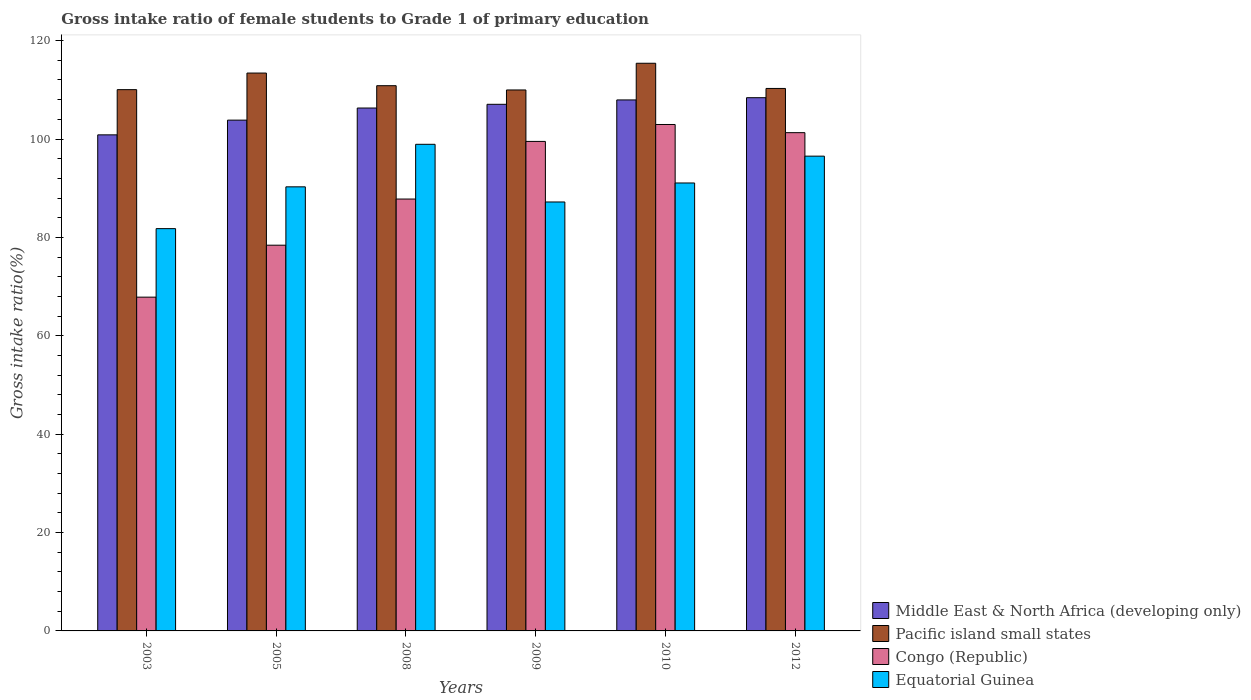How many different coloured bars are there?
Offer a terse response. 4. How many groups of bars are there?
Provide a succinct answer. 6. Are the number of bars per tick equal to the number of legend labels?
Ensure brevity in your answer.  Yes. Are the number of bars on each tick of the X-axis equal?
Provide a succinct answer. Yes. How many bars are there on the 2nd tick from the left?
Your answer should be very brief. 4. What is the label of the 6th group of bars from the left?
Keep it short and to the point. 2012. What is the gross intake ratio in Middle East & North Africa (developing only) in 2008?
Give a very brief answer. 106.3. Across all years, what is the maximum gross intake ratio in Congo (Republic)?
Ensure brevity in your answer.  102.95. Across all years, what is the minimum gross intake ratio in Pacific island small states?
Offer a very short reply. 109.97. In which year was the gross intake ratio in Middle East & North Africa (developing only) maximum?
Make the answer very short. 2012. In which year was the gross intake ratio in Pacific island small states minimum?
Provide a succinct answer. 2009. What is the total gross intake ratio in Pacific island small states in the graph?
Provide a succinct answer. 669.95. What is the difference between the gross intake ratio in Middle East & North Africa (developing only) in 2003 and that in 2008?
Offer a very short reply. -5.45. What is the difference between the gross intake ratio in Congo (Republic) in 2010 and the gross intake ratio in Equatorial Guinea in 2003?
Your answer should be compact. 21.17. What is the average gross intake ratio in Equatorial Guinea per year?
Keep it short and to the point. 90.96. In the year 2012, what is the difference between the gross intake ratio in Congo (Republic) and gross intake ratio in Equatorial Guinea?
Your response must be concise. 4.77. What is the ratio of the gross intake ratio in Equatorial Guinea in 2005 to that in 2010?
Provide a short and direct response. 0.99. What is the difference between the highest and the second highest gross intake ratio in Pacific island small states?
Your answer should be compact. 1.99. What is the difference between the highest and the lowest gross intake ratio in Pacific island small states?
Your answer should be very brief. 5.43. Is the sum of the gross intake ratio in Equatorial Guinea in 2010 and 2012 greater than the maximum gross intake ratio in Congo (Republic) across all years?
Provide a short and direct response. Yes. What does the 2nd bar from the left in 2005 represents?
Offer a very short reply. Pacific island small states. What does the 1st bar from the right in 2009 represents?
Make the answer very short. Equatorial Guinea. How many bars are there?
Provide a succinct answer. 24. How many years are there in the graph?
Make the answer very short. 6. What is the difference between two consecutive major ticks on the Y-axis?
Your response must be concise. 20. Does the graph contain grids?
Offer a very short reply. No. What is the title of the graph?
Your answer should be compact. Gross intake ratio of female students to Grade 1 of primary education. Does "St. Kitts and Nevis" appear as one of the legend labels in the graph?
Keep it short and to the point. No. What is the label or title of the Y-axis?
Your answer should be compact. Gross intake ratio(%). What is the Gross intake ratio(%) in Middle East & North Africa (developing only) in 2003?
Your answer should be compact. 100.85. What is the Gross intake ratio(%) in Pacific island small states in 2003?
Make the answer very short. 110.04. What is the Gross intake ratio(%) of Congo (Republic) in 2003?
Keep it short and to the point. 67.85. What is the Gross intake ratio(%) of Equatorial Guinea in 2003?
Provide a short and direct response. 81.78. What is the Gross intake ratio(%) in Middle East & North Africa (developing only) in 2005?
Give a very brief answer. 103.84. What is the Gross intake ratio(%) in Pacific island small states in 2005?
Provide a short and direct response. 113.41. What is the Gross intake ratio(%) in Congo (Republic) in 2005?
Provide a short and direct response. 78.42. What is the Gross intake ratio(%) of Equatorial Guinea in 2005?
Your answer should be compact. 90.28. What is the Gross intake ratio(%) in Middle East & North Africa (developing only) in 2008?
Provide a succinct answer. 106.3. What is the Gross intake ratio(%) in Pacific island small states in 2008?
Provide a short and direct response. 110.84. What is the Gross intake ratio(%) in Congo (Republic) in 2008?
Your answer should be compact. 87.8. What is the Gross intake ratio(%) of Equatorial Guinea in 2008?
Provide a short and direct response. 98.92. What is the Gross intake ratio(%) of Middle East & North Africa (developing only) in 2009?
Provide a short and direct response. 107.06. What is the Gross intake ratio(%) in Pacific island small states in 2009?
Make the answer very short. 109.97. What is the Gross intake ratio(%) in Congo (Republic) in 2009?
Give a very brief answer. 99.51. What is the Gross intake ratio(%) of Equatorial Guinea in 2009?
Keep it short and to the point. 87.2. What is the Gross intake ratio(%) in Middle East & North Africa (developing only) in 2010?
Ensure brevity in your answer.  107.95. What is the Gross intake ratio(%) in Pacific island small states in 2010?
Offer a very short reply. 115.4. What is the Gross intake ratio(%) of Congo (Republic) in 2010?
Give a very brief answer. 102.95. What is the Gross intake ratio(%) in Equatorial Guinea in 2010?
Your answer should be compact. 91.06. What is the Gross intake ratio(%) in Middle East & North Africa (developing only) in 2012?
Offer a terse response. 108.4. What is the Gross intake ratio(%) in Pacific island small states in 2012?
Your response must be concise. 110.28. What is the Gross intake ratio(%) of Congo (Republic) in 2012?
Give a very brief answer. 101.29. What is the Gross intake ratio(%) in Equatorial Guinea in 2012?
Make the answer very short. 96.52. Across all years, what is the maximum Gross intake ratio(%) in Middle East & North Africa (developing only)?
Keep it short and to the point. 108.4. Across all years, what is the maximum Gross intake ratio(%) of Pacific island small states?
Ensure brevity in your answer.  115.4. Across all years, what is the maximum Gross intake ratio(%) of Congo (Republic)?
Give a very brief answer. 102.95. Across all years, what is the maximum Gross intake ratio(%) of Equatorial Guinea?
Provide a succinct answer. 98.92. Across all years, what is the minimum Gross intake ratio(%) in Middle East & North Africa (developing only)?
Your answer should be very brief. 100.85. Across all years, what is the minimum Gross intake ratio(%) in Pacific island small states?
Provide a succinct answer. 109.97. Across all years, what is the minimum Gross intake ratio(%) in Congo (Republic)?
Your response must be concise. 67.85. Across all years, what is the minimum Gross intake ratio(%) in Equatorial Guinea?
Ensure brevity in your answer.  81.78. What is the total Gross intake ratio(%) in Middle East & North Africa (developing only) in the graph?
Provide a short and direct response. 634.39. What is the total Gross intake ratio(%) in Pacific island small states in the graph?
Your response must be concise. 669.95. What is the total Gross intake ratio(%) in Congo (Republic) in the graph?
Offer a very short reply. 537.83. What is the total Gross intake ratio(%) in Equatorial Guinea in the graph?
Give a very brief answer. 545.77. What is the difference between the Gross intake ratio(%) of Middle East & North Africa (developing only) in 2003 and that in 2005?
Your answer should be very brief. -2.99. What is the difference between the Gross intake ratio(%) in Pacific island small states in 2003 and that in 2005?
Make the answer very short. -3.37. What is the difference between the Gross intake ratio(%) of Congo (Republic) in 2003 and that in 2005?
Your response must be concise. -10.56. What is the difference between the Gross intake ratio(%) in Equatorial Guinea in 2003 and that in 2005?
Offer a terse response. -8.5. What is the difference between the Gross intake ratio(%) of Middle East & North Africa (developing only) in 2003 and that in 2008?
Your response must be concise. -5.45. What is the difference between the Gross intake ratio(%) of Pacific island small states in 2003 and that in 2008?
Offer a very short reply. -0.8. What is the difference between the Gross intake ratio(%) of Congo (Republic) in 2003 and that in 2008?
Ensure brevity in your answer.  -19.94. What is the difference between the Gross intake ratio(%) in Equatorial Guinea in 2003 and that in 2008?
Provide a short and direct response. -17.14. What is the difference between the Gross intake ratio(%) in Middle East & North Africa (developing only) in 2003 and that in 2009?
Your answer should be compact. -6.21. What is the difference between the Gross intake ratio(%) of Pacific island small states in 2003 and that in 2009?
Offer a terse response. 0.06. What is the difference between the Gross intake ratio(%) in Congo (Republic) in 2003 and that in 2009?
Give a very brief answer. -31.66. What is the difference between the Gross intake ratio(%) of Equatorial Guinea in 2003 and that in 2009?
Offer a very short reply. -5.42. What is the difference between the Gross intake ratio(%) of Middle East & North Africa (developing only) in 2003 and that in 2010?
Make the answer very short. -7.1. What is the difference between the Gross intake ratio(%) in Pacific island small states in 2003 and that in 2010?
Ensure brevity in your answer.  -5.36. What is the difference between the Gross intake ratio(%) in Congo (Republic) in 2003 and that in 2010?
Keep it short and to the point. -35.1. What is the difference between the Gross intake ratio(%) of Equatorial Guinea in 2003 and that in 2010?
Offer a very short reply. -9.28. What is the difference between the Gross intake ratio(%) of Middle East & North Africa (developing only) in 2003 and that in 2012?
Give a very brief answer. -7.55. What is the difference between the Gross intake ratio(%) in Pacific island small states in 2003 and that in 2012?
Provide a short and direct response. -0.24. What is the difference between the Gross intake ratio(%) in Congo (Republic) in 2003 and that in 2012?
Offer a terse response. -33.44. What is the difference between the Gross intake ratio(%) of Equatorial Guinea in 2003 and that in 2012?
Offer a terse response. -14.74. What is the difference between the Gross intake ratio(%) of Middle East & North Africa (developing only) in 2005 and that in 2008?
Offer a terse response. -2.46. What is the difference between the Gross intake ratio(%) of Pacific island small states in 2005 and that in 2008?
Your answer should be compact. 2.57. What is the difference between the Gross intake ratio(%) of Congo (Republic) in 2005 and that in 2008?
Provide a short and direct response. -9.38. What is the difference between the Gross intake ratio(%) in Equatorial Guinea in 2005 and that in 2008?
Provide a short and direct response. -8.64. What is the difference between the Gross intake ratio(%) in Middle East & North Africa (developing only) in 2005 and that in 2009?
Your response must be concise. -3.22. What is the difference between the Gross intake ratio(%) of Pacific island small states in 2005 and that in 2009?
Make the answer very short. 3.43. What is the difference between the Gross intake ratio(%) in Congo (Republic) in 2005 and that in 2009?
Offer a very short reply. -21.1. What is the difference between the Gross intake ratio(%) of Equatorial Guinea in 2005 and that in 2009?
Your answer should be compact. 3.08. What is the difference between the Gross intake ratio(%) in Middle East & North Africa (developing only) in 2005 and that in 2010?
Ensure brevity in your answer.  -4.11. What is the difference between the Gross intake ratio(%) of Pacific island small states in 2005 and that in 2010?
Ensure brevity in your answer.  -1.99. What is the difference between the Gross intake ratio(%) in Congo (Republic) in 2005 and that in 2010?
Ensure brevity in your answer.  -24.54. What is the difference between the Gross intake ratio(%) of Equatorial Guinea in 2005 and that in 2010?
Your answer should be compact. -0.78. What is the difference between the Gross intake ratio(%) of Middle East & North Africa (developing only) in 2005 and that in 2012?
Your answer should be very brief. -4.56. What is the difference between the Gross intake ratio(%) of Pacific island small states in 2005 and that in 2012?
Offer a very short reply. 3.13. What is the difference between the Gross intake ratio(%) of Congo (Republic) in 2005 and that in 2012?
Your answer should be compact. -22.88. What is the difference between the Gross intake ratio(%) in Equatorial Guinea in 2005 and that in 2012?
Provide a succinct answer. -6.24. What is the difference between the Gross intake ratio(%) of Middle East & North Africa (developing only) in 2008 and that in 2009?
Provide a short and direct response. -0.76. What is the difference between the Gross intake ratio(%) in Pacific island small states in 2008 and that in 2009?
Your answer should be compact. 0.87. What is the difference between the Gross intake ratio(%) in Congo (Republic) in 2008 and that in 2009?
Provide a short and direct response. -11.71. What is the difference between the Gross intake ratio(%) of Equatorial Guinea in 2008 and that in 2009?
Give a very brief answer. 11.72. What is the difference between the Gross intake ratio(%) in Middle East & North Africa (developing only) in 2008 and that in 2010?
Give a very brief answer. -1.65. What is the difference between the Gross intake ratio(%) of Pacific island small states in 2008 and that in 2010?
Make the answer very short. -4.56. What is the difference between the Gross intake ratio(%) in Congo (Republic) in 2008 and that in 2010?
Your answer should be very brief. -15.15. What is the difference between the Gross intake ratio(%) of Equatorial Guinea in 2008 and that in 2010?
Ensure brevity in your answer.  7.86. What is the difference between the Gross intake ratio(%) of Middle East & North Africa (developing only) in 2008 and that in 2012?
Ensure brevity in your answer.  -2.1. What is the difference between the Gross intake ratio(%) in Pacific island small states in 2008 and that in 2012?
Provide a short and direct response. 0.56. What is the difference between the Gross intake ratio(%) in Congo (Republic) in 2008 and that in 2012?
Make the answer very short. -13.49. What is the difference between the Gross intake ratio(%) in Equatorial Guinea in 2008 and that in 2012?
Offer a very short reply. 2.41. What is the difference between the Gross intake ratio(%) in Middle East & North Africa (developing only) in 2009 and that in 2010?
Provide a succinct answer. -0.89. What is the difference between the Gross intake ratio(%) in Pacific island small states in 2009 and that in 2010?
Your answer should be very brief. -5.43. What is the difference between the Gross intake ratio(%) in Congo (Republic) in 2009 and that in 2010?
Provide a succinct answer. -3.44. What is the difference between the Gross intake ratio(%) of Equatorial Guinea in 2009 and that in 2010?
Your response must be concise. -3.86. What is the difference between the Gross intake ratio(%) in Middle East & North Africa (developing only) in 2009 and that in 2012?
Offer a very short reply. -1.35. What is the difference between the Gross intake ratio(%) of Pacific island small states in 2009 and that in 2012?
Offer a very short reply. -0.31. What is the difference between the Gross intake ratio(%) of Congo (Republic) in 2009 and that in 2012?
Your response must be concise. -1.78. What is the difference between the Gross intake ratio(%) of Equatorial Guinea in 2009 and that in 2012?
Ensure brevity in your answer.  -9.32. What is the difference between the Gross intake ratio(%) of Middle East & North Africa (developing only) in 2010 and that in 2012?
Make the answer very short. -0.45. What is the difference between the Gross intake ratio(%) of Pacific island small states in 2010 and that in 2012?
Offer a terse response. 5.12. What is the difference between the Gross intake ratio(%) in Congo (Republic) in 2010 and that in 2012?
Keep it short and to the point. 1.66. What is the difference between the Gross intake ratio(%) of Equatorial Guinea in 2010 and that in 2012?
Provide a succinct answer. -5.46. What is the difference between the Gross intake ratio(%) of Middle East & North Africa (developing only) in 2003 and the Gross intake ratio(%) of Pacific island small states in 2005?
Offer a terse response. -12.56. What is the difference between the Gross intake ratio(%) in Middle East & North Africa (developing only) in 2003 and the Gross intake ratio(%) in Congo (Republic) in 2005?
Ensure brevity in your answer.  22.43. What is the difference between the Gross intake ratio(%) of Middle East & North Africa (developing only) in 2003 and the Gross intake ratio(%) of Equatorial Guinea in 2005?
Provide a succinct answer. 10.57. What is the difference between the Gross intake ratio(%) in Pacific island small states in 2003 and the Gross intake ratio(%) in Congo (Republic) in 2005?
Provide a short and direct response. 31.62. What is the difference between the Gross intake ratio(%) in Pacific island small states in 2003 and the Gross intake ratio(%) in Equatorial Guinea in 2005?
Provide a short and direct response. 19.76. What is the difference between the Gross intake ratio(%) in Congo (Republic) in 2003 and the Gross intake ratio(%) in Equatorial Guinea in 2005?
Offer a very short reply. -22.43. What is the difference between the Gross intake ratio(%) in Middle East & North Africa (developing only) in 2003 and the Gross intake ratio(%) in Pacific island small states in 2008?
Ensure brevity in your answer.  -9.99. What is the difference between the Gross intake ratio(%) in Middle East & North Africa (developing only) in 2003 and the Gross intake ratio(%) in Congo (Republic) in 2008?
Provide a succinct answer. 13.05. What is the difference between the Gross intake ratio(%) of Middle East & North Africa (developing only) in 2003 and the Gross intake ratio(%) of Equatorial Guinea in 2008?
Your answer should be compact. 1.92. What is the difference between the Gross intake ratio(%) of Pacific island small states in 2003 and the Gross intake ratio(%) of Congo (Republic) in 2008?
Give a very brief answer. 22.24. What is the difference between the Gross intake ratio(%) of Pacific island small states in 2003 and the Gross intake ratio(%) of Equatorial Guinea in 2008?
Give a very brief answer. 11.11. What is the difference between the Gross intake ratio(%) of Congo (Republic) in 2003 and the Gross intake ratio(%) of Equatorial Guinea in 2008?
Your answer should be compact. -31.07. What is the difference between the Gross intake ratio(%) in Middle East & North Africa (developing only) in 2003 and the Gross intake ratio(%) in Pacific island small states in 2009?
Ensure brevity in your answer.  -9.13. What is the difference between the Gross intake ratio(%) in Middle East & North Africa (developing only) in 2003 and the Gross intake ratio(%) in Congo (Republic) in 2009?
Offer a very short reply. 1.33. What is the difference between the Gross intake ratio(%) in Middle East & North Africa (developing only) in 2003 and the Gross intake ratio(%) in Equatorial Guinea in 2009?
Offer a very short reply. 13.65. What is the difference between the Gross intake ratio(%) in Pacific island small states in 2003 and the Gross intake ratio(%) in Congo (Republic) in 2009?
Provide a short and direct response. 10.52. What is the difference between the Gross intake ratio(%) in Pacific island small states in 2003 and the Gross intake ratio(%) in Equatorial Guinea in 2009?
Provide a succinct answer. 22.84. What is the difference between the Gross intake ratio(%) of Congo (Republic) in 2003 and the Gross intake ratio(%) of Equatorial Guinea in 2009?
Your response must be concise. -19.35. What is the difference between the Gross intake ratio(%) of Middle East & North Africa (developing only) in 2003 and the Gross intake ratio(%) of Pacific island small states in 2010?
Ensure brevity in your answer.  -14.55. What is the difference between the Gross intake ratio(%) of Middle East & North Africa (developing only) in 2003 and the Gross intake ratio(%) of Congo (Republic) in 2010?
Your answer should be very brief. -2.1. What is the difference between the Gross intake ratio(%) in Middle East & North Africa (developing only) in 2003 and the Gross intake ratio(%) in Equatorial Guinea in 2010?
Provide a short and direct response. 9.79. What is the difference between the Gross intake ratio(%) of Pacific island small states in 2003 and the Gross intake ratio(%) of Congo (Republic) in 2010?
Keep it short and to the point. 7.09. What is the difference between the Gross intake ratio(%) of Pacific island small states in 2003 and the Gross intake ratio(%) of Equatorial Guinea in 2010?
Provide a succinct answer. 18.98. What is the difference between the Gross intake ratio(%) of Congo (Republic) in 2003 and the Gross intake ratio(%) of Equatorial Guinea in 2010?
Offer a terse response. -23.21. What is the difference between the Gross intake ratio(%) in Middle East & North Africa (developing only) in 2003 and the Gross intake ratio(%) in Pacific island small states in 2012?
Make the answer very short. -9.43. What is the difference between the Gross intake ratio(%) of Middle East & North Africa (developing only) in 2003 and the Gross intake ratio(%) of Congo (Republic) in 2012?
Your response must be concise. -0.44. What is the difference between the Gross intake ratio(%) in Middle East & North Africa (developing only) in 2003 and the Gross intake ratio(%) in Equatorial Guinea in 2012?
Ensure brevity in your answer.  4.33. What is the difference between the Gross intake ratio(%) of Pacific island small states in 2003 and the Gross intake ratio(%) of Congo (Republic) in 2012?
Keep it short and to the point. 8.75. What is the difference between the Gross intake ratio(%) in Pacific island small states in 2003 and the Gross intake ratio(%) in Equatorial Guinea in 2012?
Offer a very short reply. 13.52. What is the difference between the Gross intake ratio(%) in Congo (Republic) in 2003 and the Gross intake ratio(%) in Equatorial Guinea in 2012?
Provide a short and direct response. -28.66. What is the difference between the Gross intake ratio(%) of Middle East & North Africa (developing only) in 2005 and the Gross intake ratio(%) of Pacific island small states in 2008?
Give a very brief answer. -7. What is the difference between the Gross intake ratio(%) of Middle East & North Africa (developing only) in 2005 and the Gross intake ratio(%) of Congo (Republic) in 2008?
Provide a short and direct response. 16.04. What is the difference between the Gross intake ratio(%) of Middle East & North Africa (developing only) in 2005 and the Gross intake ratio(%) of Equatorial Guinea in 2008?
Ensure brevity in your answer.  4.91. What is the difference between the Gross intake ratio(%) of Pacific island small states in 2005 and the Gross intake ratio(%) of Congo (Republic) in 2008?
Keep it short and to the point. 25.61. What is the difference between the Gross intake ratio(%) of Pacific island small states in 2005 and the Gross intake ratio(%) of Equatorial Guinea in 2008?
Give a very brief answer. 14.48. What is the difference between the Gross intake ratio(%) of Congo (Republic) in 2005 and the Gross intake ratio(%) of Equatorial Guinea in 2008?
Offer a very short reply. -20.51. What is the difference between the Gross intake ratio(%) of Middle East & North Africa (developing only) in 2005 and the Gross intake ratio(%) of Pacific island small states in 2009?
Ensure brevity in your answer.  -6.14. What is the difference between the Gross intake ratio(%) of Middle East & North Africa (developing only) in 2005 and the Gross intake ratio(%) of Congo (Republic) in 2009?
Your answer should be very brief. 4.32. What is the difference between the Gross intake ratio(%) in Middle East & North Africa (developing only) in 2005 and the Gross intake ratio(%) in Equatorial Guinea in 2009?
Ensure brevity in your answer.  16.64. What is the difference between the Gross intake ratio(%) of Pacific island small states in 2005 and the Gross intake ratio(%) of Congo (Republic) in 2009?
Give a very brief answer. 13.89. What is the difference between the Gross intake ratio(%) of Pacific island small states in 2005 and the Gross intake ratio(%) of Equatorial Guinea in 2009?
Provide a short and direct response. 26.21. What is the difference between the Gross intake ratio(%) of Congo (Republic) in 2005 and the Gross intake ratio(%) of Equatorial Guinea in 2009?
Your answer should be very brief. -8.79. What is the difference between the Gross intake ratio(%) in Middle East & North Africa (developing only) in 2005 and the Gross intake ratio(%) in Pacific island small states in 2010?
Ensure brevity in your answer.  -11.56. What is the difference between the Gross intake ratio(%) of Middle East & North Africa (developing only) in 2005 and the Gross intake ratio(%) of Congo (Republic) in 2010?
Keep it short and to the point. 0.89. What is the difference between the Gross intake ratio(%) in Middle East & North Africa (developing only) in 2005 and the Gross intake ratio(%) in Equatorial Guinea in 2010?
Your answer should be compact. 12.78. What is the difference between the Gross intake ratio(%) of Pacific island small states in 2005 and the Gross intake ratio(%) of Congo (Republic) in 2010?
Make the answer very short. 10.46. What is the difference between the Gross intake ratio(%) of Pacific island small states in 2005 and the Gross intake ratio(%) of Equatorial Guinea in 2010?
Your answer should be very brief. 22.35. What is the difference between the Gross intake ratio(%) of Congo (Republic) in 2005 and the Gross intake ratio(%) of Equatorial Guinea in 2010?
Your response must be concise. -12.65. What is the difference between the Gross intake ratio(%) of Middle East & North Africa (developing only) in 2005 and the Gross intake ratio(%) of Pacific island small states in 2012?
Your answer should be very brief. -6.44. What is the difference between the Gross intake ratio(%) in Middle East & North Africa (developing only) in 2005 and the Gross intake ratio(%) in Congo (Republic) in 2012?
Provide a short and direct response. 2.55. What is the difference between the Gross intake ratio(%) in Middle East & North Africa (developing only) in 2005 and the Gross intake ratio(%) in Equatorial Guinea in 2012?
Provide a succinct answer. 7.32. What is the difference between the Gross intake ratio(%) of Pacific island small states in 2005 and the Gross intake ratio(%) of Congo (Republic) in 2012?
Offer a terse response. 12.12. What is the difference between the Gross intake ratio(%) of Pacific island small states in 2005 and the Gross intake ratio(%) of Equatorial Guinea in 2012?
Ensure brevity in your answer.  16.89. What is the difference between the Gross intake ratio(%) in Congo (Republic) in 2005 and the Gross intake ratio(%) in Equatorial Guinea in 2012?
Offer a very short reply. -18.1. What is the difference between the Gross intake ratio(%) in Middle East & North Africa (developing only) in 2008 and the Gross intake ratio(%) in Pacific island small states in 2009?
Your answer should be compact. -3.67. What is the difference between the Gross intake ratio(%) in Middle East & North Africa (developing only) in 2008 and the Gross intake ratio(%) in Congo (Republic) in 2009?
Make the answer very short. 6.79. What is the difference between the Gross intake ratio(%) of Middle East & North Africa (developing only) in 2008 and the Gross intake ratio(%) of Equatorial Guinea in 2009?
Your answer should be very brief. 19.1. What is the difference between the Gross intake ratio(%) in Pacific island small states in 2008 and the Gross intake ratio(%) in Congo (Republic) in 2009?
Your answer should be compact. 11.33. What is the difference between the Gross intake ratio(%) of Pacific island small states in 2008 and the Gross intake ratio(%) of Equatorial Guinea in 2009?
Give a very brief answer. 23.64. What is the difference between the Gross intake ratio(%) in Congo (Republic) in 2008 and the Gross intake ratio(%) in Equatorial Guinea in 2009?
Offer a terse response. 0.6. What is the difference between the Gross intake ratio(%) in Middle East & North Africa (developing only) in 2008 and the Gross intake ratio(%) in Pacific island small states in 2010?
Ensure brevity in your answer.  -9.1. What is the difference between the Gross intake ratio(%) in Middle East & North Africa (developing only) in 2008 and the Gross intake ratio(%) in Congo (Republic) in 2010?
Give a very brief answer. 3.35. What is the difference between the Gross intake ratio(%) in Middle East & North Africa (developing only) in 2008 and the Gross intake ratio(%) in Equatorial Guinea in 2010?
Your answer should be very brief. 15.24. What is the difference between the Gross intake ratio(%) in Pacific island small states in 2008 and the Gross intake ratio(%) in Congo (Republic) in 2010?
Your answer should be very brief. 7.89. What is the difference between the Gross intake ratio(%) of Pacific island small states in 2008 and the Gross intake ratio(%) of Equatorial Guinea in 2010?
Your response must be concise. 19.78. What is the difference between the Gross intake ratio(%) of Congo (Republic) in 2008 and the Gross intake ratio(%) of Equatorial Guinea in 2010?
Provide a short and direct response. -3.26. What is the difference between the Gross intake ratio(%) in Middle East & North Africa (developing only) in 2008 and the Gross intake ratio(%) in Pacific island small states in 2012?
Keep it short and to the point. -3.98. What is the difference between the Gross intake ratio(%) in Middle East & North Africa (developing only) in 2008 and the Gross intake ratio(%) in Congo (Republic) in 2012?
Your answer should be compact. 5.01. What is the difference between the Gross intake ratio(%) in Middle East & North Africa (developing only) in 2008 and the Gross intake ratio(%) in Equatorial Guinea in 2012?
Your answer should be very brief. 9.78. What is the difference between the Gross intake ratio(%) in Pacific island small states in 2008 and the Gross intake ratio(%) in Congo (Republic) in 2012?
Your answer should be compact. 9.55. What is the difference between the Gross intake ratio(%) of Pacific island small states in 2008 and the Gross intake ratio(%) of Equatorial Guinea in 2012?
Provide a short and direct response. 14.32. What is the difference between the Gross intake ratio(%) in Congo (Republic) in 2008 and the Gross intake ratio(%) in Equatorial Guinea in 2012?
Your response must be concise. -8.72. What is the difference between the Gross intake ratio(%) of Middle East & North Africa (developing only) in 2009 and the Gross intake ratio(%) of Pacific island small states in 2010?
Provide a short and direct response. -8.35. What is the difference between the Gross intake ratio(%) in Middle East & North Africa (developing only) in 2009 and the Gross intake ratio(%) in Congo (Republic) in 2010?
Keep it short and to the point. 4.1. What is the difference between the Gross intake ratio(%) in Middle East & North Africa (developing only) in 2009 and the Gross intake ratio(%) in Equatorial Guinea in 2010?
Your response must be concise. 15.99. What is the difference between the Gross intake ratio(%) of Pacific island small states in 2009 and the Gross intake ratio(%) of Congo (Republic) in 2010?
Ensure brevity in your answer.  7.02. What is the difference between the Gross intake ratio(%) of Pacific island small states in 2009 and the Gross intake ratio(%) of Equatorial Guinea in 2010?
Ensure brevity in your answer.  18.91. What is the difference between the Gross intake ratio(%) in Congo (Republic) in 2009 and the Gross intake ratio(%) in Equatorial Guinea in 2010?
Provide a short and direct response. 8.45. What is the difference between the Gross intake ratio(%) of Middle East & North Africa (developing only) in 2009 and the Gross intake ratio(%) of Pacific island small states in 2012?
Offer a very short reply. -3.23. What is the difference between the Gross intake ratio(%) of Middle East & North Africa (developing only) in 2009 and the Gross intake ratio(%) of Congo (Republic) in 2012?
Your answer should be compact. 5.76. What is the difference between the Gross intake ratio(%) in Middle East & North Africa (developing only) in 2009 and the Gross intake ratio(%) in Equatorial Guinea in 2012?
Offer a terse response. 10.54. What is the difference between the Gross intake ratio(%) of Pacific island small states in 2009 and the Gross intake ratio(%) of Congo (Republic) in 2012?
Your answer should be very brief. 8.68. What is the difference between the Gross intake ratio(%) in Pacific island small states in 2009 and the Gross intake ratio(%) in Equatorial Guinea in 2012?
Provide a short and direct response. 13.46. What is the difference between the Gross intake ratio(%) of Congo (Republic) in 2009 and the Gross intake ratio(%) of Equatorial Guinea in 2012?
Offer a very short reply. 3. What is the difference between the Gross intake ratio(%) of Middle East & North Africa (developing only) in 2010 and the Gross intake ratio(%) of Pacific island small states in 2012?
Ensure brevity in your answer.  -2.33. What is the difference between the Gross intake ratio(%) in Middle East & North Africa (developing only) in 2010 and the Gross intake ratio(%) in Congo (Republic) in 2012?
Give a very brief answer. 6.66. What is the difference between the Gross intake ratio(%) of Middle East & North Africa (developing only) in 2010 and the Gross intake ratio(%) of Equatorial Guinea in 2012?
Give a very brief answer. 11.43. What is the difference between the Gross intake ratio(%) in Pacific island small states in 2010 and the Gross intake ratio(%) in Congo (Republic) in 2012?
Offer a terse response. 14.11. What is the difference between the Gross intake ratio(%) of Pacific island small states in 2010 and the Gross intake ratio(%) of Equatorial Guinea in 2012?
Keep it short and to the point. 18.88. What is the difference between the Gross intake ratio(%) in Congo (Republic) in 2010 and the Gross intake ratio(%) in Equatorial Guinea in 2012?
Keep it short and to the point. 6.43. What is the average Gross intake ratio(%) of Middle East & North Africa (developing only) per year?
Give a very brief answer. 105.73. What is the average Gross intake ratio(%) in Pacific island small states per year?
Your answer should be compact. 111.66. What is the average Gross intake ratio(%) in Congo (Republic) per year?
Ensure brevity in your answer.  89.64. What is the average Gross intake ratio(%) in Equatorial Guinea per year?
Make the answer very short. 90.96. In the year 2003, what is the difference between the Gross intake ratio(%) of Middle East & North Africa (developing only) and Gross intake ratio(%) of Pacific island small states?
Provide a succinct answer. -9.19. In the year 2003, what is the difference between the Gross intake ratio(%) of Middle East & North Africa (developing only) and Gross intake ratio(%) of Congo (Republic)?
Your answer should be very brief. 32.99. In the year 2003, what is the difference between the Gross intake ratio(%) of Middle East & North Africa (developing only) and Gross intake ratio(%) of Equatorial Guinea?
Provide a succinct answer. 19.07. In the year 2003, what is the difference between the Gross intake ratio(%) in Pacific island small states and Gross intake ratio(%) in Congo (Republic)?
Give a very brief answer. 42.18. In the year 2003, what is the difference between the Gross intake ratio(%) of Pacific island small states and Gross intake ratio(%) of Equatorial Guinea?
Your answer should be compact. 28.26. In the year 2003, what is the difference between the Gross intake ratio(%) of Congo (Republic) and Gross intake ratio(%) of Equatorial Guinea?
Provide a short and direct response. -13.93. In the year 2005, what is the difference between the Gross intake ratio(%) of Middle East & North Africa (developing only) and Gross intake ratio(%) of Pacific island small states?
Your response must be concise. -9.57. In the year 2005, what is the difference between the Gross intake ratio(%) of Middle East & North Africa (developing only) and Gross intake ratio(%) of Congo (Republic)?
Ensure brevity in your answer.  25.42. In the year 2005, what is the difference between the Gross intake ratio(%) of Middle East & North Africa (developing only) and Gross intake ratio(%) of Equatorial Guinea?
Provide a short and direct response. 13.56. In the year 2005, what is the difference between the Gross intake ratio(%) in Pacific island small states and Gross intake ratio(%) in Congo (Republic)?
Provide a succinct answer. 34.99. In the year 2005, what is the difference between the Gross intake ratio(%) of Pacific island small states and Gross intake ratio(%) of Equatorial Guinea?
Your answer should be compact. 23.13. In the year 2005, what is the difference between the Gross intake ratio(%) of Congo (Republic) and Gross intake ratio(%) of Equatorial Guinea?
Give a very brief answer. -11.86. In the year 2008, what is the difference between the Gross intake ratio(%) of Middle East & North Africa (developing only) and Gross intake ratio(%) of Pacific island small states?
Your answer should be very brief. -4.54. In the year 2008, what is the difference between the Gross intake ratio(%) in Middle East & North Africa (developing only) and Gross intake ratio(%) in Congo (Republic)?
Your answer should be very brief. 18.5. In the year 2008, what is the difference between the Gross intake ratio(%) in Middle East & North Africa (developing only) and Gross intake ratio(%) in Equatorial Guinea?
Provide a short and direct response. 7.38. In the year 2008, what is the difference between the Gross intake ratio(%) in Pacific island small states and Gross intake ratio(%) in Congo (Republic)?
Ensure brevity in your answer.  23.04. In the year 2008, what is the difference between the Gross intake ratio(%) of Pacific island small states and Gross intake ratio(%) of Equatorial Guinea?
Offer a terse response. 11.92. In the year 2008, what is the difference between the Gross intake ratio(%) of Congo (Republic) and Gross intake ratio(%) of Equatorial Guinea?
Keep it short and to the point. -11.12. In the year 2009, what is the difference between the Gross intake ratio(%) of Middle East & North Africa (developing only) and Gross intake ratio(%) of Pacific island small states?
Keep it short and to the point. -2.92. In the year 2009, what is the difference between the Gross intake ratio(%) of Middle East & North Africa (developing only) and Gross intake ratio(%) of Congo (Republic)?
Offer a terse response. 7.54. In the year 2009, what is the difference between the Gross intake ratio(%) of Middle East & North Africa (developing only) and Gross intake ratio(%) of Equatorial Guinea?
Give a very brief answer. 19.86. In the year 2009, what is the difference between the Gross intake ratio(%) of Pacific island small states and Gross intake ratio(%) of Congo (Republic)?
Keep it short and to the point. 10.46. In the year 2009, what is the difference between the Gross intake ratio(%) of Pacific island small states and Gross intake ratio(%) of Equatorial Guinea?
Your answer should be compact. 22.77. In the year 2009, what is the difference between the Gross intake ratio(%) of Congo (Republic) and Gross intake ratio(%) of Equatorial Guinea?
Provide a short and direct response. 12.31. In the year 2010, what is the difference between the Gross intake ratio(%) of Middle East & North Africa (developing only) and Gross intake ratio(%) of Pacific island small states?
Make the answer very short. -7.45. In the year 2010, what is the difference between the Gross intake ratio(%) of Middle East & North Africa (developing only) and Gross intake ratio(%) of Congo (Republic)?
Offer a very short reply. 5. In the year 2010, what is the difference between the Gross intake ratio(%) of Middle East & North Africa (developing only) and Gross intake ratio(%) of Equatorial Guinea?
Give a very brief answer. 16.89. In the year 2010, what is the difference between the Gross intake ratio(%) of Pacific island small states and Gross intake ratio(%) of Congo (Republic)?
Your answer should be compact. 12.45. In the year 2010, what is the difference between the Gross intake ratio(%) in Pacific island small states and Gross intake ratio(%) in Equatorial Guinea?
Offer a terse response. 24.34. In the year 2010, what is the difference between the Gross intake ratio(%) in Congo (Republic) and Gross intake ratio(%) in Equatorial Guinea?
Give a very brief answer. 11.89. In the year 2012, what is the difference between the Gross intake ratio(%) in Middle East & North Africa (developing only) and Gross intake ratio(%) in Pacific island small states?
Offer a very short reply. -1.88. In the year 2012, what is the difference between the Gross intake ratio(%) of Middle East & North Africa (developing only) and Gross intake ratio(%) of Congo (Republic)?
Make the answer very short. 7.11. In the year 2012, what is the difference between the Gross intake ratio(%) in Middle East & North Africa (developing only) and Gross intake ratio(%) in Equatorial Guinea?
Your response must be concise. 11.88. In the year 2012, what is the difference between the Gross intake ratio(%) of Pacific island small states and Gross intake ratio(%) of Congo (Republic)?
Make the answer very short. 8.99. In the year 2012, what is the difference between the Gross intake ratio(%) in Pacific island small states and Gross intake ratio(%) in Equatorial Guinea?
Your answer should be compact. 13.76. In the year 2012, what is the difference between the Gross intake ratio(%) of Congo (Republic) and Gross intake ratio(%) of Equatorial Guinea?
Keep it short and to the point. 4.77. What is the ratio of the Gross intake ratio(%) in Middle East & North Africa (developing only) in 2003 to that in 2005?
Keep it short and to the point. 0.97. What is the ratio of the Gross intake ratio(%) in Pacific island small states in 2003 to that in 2005?
Ensure brevity in your answer.  0.97. What is the ratio of the Gross intake ratio(%) of Congo (Republic) in 2003 to that in 2005?
Provide a short and direct response. 0.87. What is the ratio of the Gross intake ratio(%) of Equatorial Guinea in 2003 to that in 2005?
Make the answer very short. 0.91. What is the ratio of the Gross intake ratio(%) in Middle East & North Africa (developing only) in 2003 to that in 2008?
Your response must be concise. 0.95. What is the ratio of the Gross intake ratio(%) in Congo (Republic) in 2003 to that in 2008?
Keep it short and to the point. 0.77. What is the ratio of the Gross intake ratio(%) in Equatorial Guinea in 2003 to that in 2008?
Provide a succinct answer. 0.83. What is the ratio of the Gross intake ratio(%) of Middle East & North Africa (developing only) in 2003 to that in 2009?
Your answer should be very brief. 0.94. What is the ratio of the Gross intake ratio(%) in Pacific island small states in 2003 to that in 2009?
Keep it short and to the point. 1. What is the ratio of the Gross intake ratio(%) of Congo (Republic) in 2003 to that in 2009?
Offer a terse response. 0.68. What is the ratio of the Gross intake ratio(%) of Equatorial Guinea in 2003 to that in 2009?
Provide a short and direct response. 0.94. What is the ratio of the Gross intake ratio(%) in Middle East & North Africa (developing only) in 2003 to that in 2010?
Make the answer very short. 0.93. What is the ratio of the Gross intake ratio(%) of Pacific island small states in 2003 to that in 2010?
Give a very brief answer. 0.95. What is the ratio of the Gross intake ratio(%) in Congo (Republic) in 2003 to that in 2010?
Your answer should be very brief. 0.66. What is the ratio of the Gross intake ratio(%) of Equatorial Guinea in 2003 to that in 2010?
Your answer should be very brief. 0.9. What is the ratio of the Gross intake ratio(%) of Middle East & North Africa (developing only) in 2003 to that in 2012?
Provide a succinct answer. 0.93. What is the ratio of the Gross intake ratio(%) in Congo (Republic) in 2003 to that in 2012?
Your answer should be very brief. 0.67. What is the ratio of the Gross intake ratio(%) in Equatorial Guinea in 2003 to that in 2012?
Your response must be concise. 0.85. What is the ratio of the Gross intake ratio(%) in Middle East & North Africa (developing only) in 2005 to that in 2008?
Your answer should be compact. 0.98. What is the ratio of the Gross intake ratio(%) in Pacific island small states in 2005 to that in 2008?
Ensure brevity in your answer.  1.02. What is the ratio of the Gross intake ratio(%) of Congo (Republic) in 2005 to that in 2008?
Keep it short and to the point. 0.89. What is the ratio of the Gross intake ratio(%) in Equatorial Guinea in 2005 to that in 2008?
Offer a terse response. 0.91. What is the ratio of the Gross intake ratio(%) of Pacific island small states in 2005 to that in 2009?
Provide a succinct answer. 1.03. What is the ratio of the Gross intake ratio(%) in Congo (Republic) in 2005 to that in 2009?
Provide a short and direct response. 0.79. What is the ratio of the Gross intake ratio(%) in Equatorial Guinea in 2005 to that in 2009?
Your answer should be very brief. 1.04. What is the ratio of the Gross intake ratio(%) in Middle East & North Africa (developing only) in 2005 to that in 2010?
Your answer should be very brief. 0.96. What is the ratio of the Gross intake ratio(%) of Pacific island small states in 2005 to that in 2010?
Make the answer very short. 0.98. What is the ratio of the Gross intake ratio(%) of Congo (Republic) in 2005 to that in 2010?
Make the answer very short. 0.76. What is the ratio of the Gross intake ratio(%) in Equatorial Guinea in 2005 to that in 2010?
Your response must be concise. 0.99. What is the ratio of the Gross intake ratio(%) of Middle East & North Africa (developing only) in 2005 to that in 2012?
Keep it short and to the point. 0.96. What is the ratio of the Gross intake ratio(%) in Pacific island small states in 2005 to that in 2012?
Ensure brevity in your answer.  1.03. What is the ratio of the Gross intake ratio(%) of Congo (Republic) in 2005 to that in 2012?
Give a very brief answer. 0.77. What is the ratio of the Gross intake ratio(%) of Equatorial Guinea in 2005 to that in 2012?
Offer a terse response. 0.94. What is the ratio of the Gross intake ratio(%) in Pacific island small states in 2008 to that in 2009?
Offer a terse response. 1.01. What is the ratio of the Gross intake ratio(%) in Congo (Republic) in 2008 to that in 2009?
Provide a succinct answer. 0.88. What is the ratio of the Gross intake ratio(%) of Equatorial Guinea in 2008 to that in 2009?
Your answer should be very brief. 1.13. What is the ratio of the Gross intake ratio(%) of Middle East & North Africa (developing only) in 2008 to that in 2010?
Give a very brief answer. 0.98. What is the ratio of the Gross intake ratio(%) in Pacific island small states in 2008 to that in 2010?
Keep it short and to the point. 0.96. What is the ratio of the Gross intake ratio(%) of Congo (Republic) in 2008 to that in 2010?
Offer a very short reply. 0.85. What is the ratio of the Gross intake ratio(%) in Equatorial Guinea in 2008 to that in 2010?
Provide a short and direct response. 1.09. What is the ratio of the Gross intake ratio(%) in Middle East & North Africa (developing only) in 2008 to that in 2012?
Offer a terse response. 0.98. What is the ratio of the Gross intake ratio(%) of Pacific island small states in 2008 to that in 2012?
Your response must be concise. 1.01. What is the ratio of the Gross intake ratio(%) of Congo (Republic) in 2008 to that in 2012?
Make the answer very short. 0.87. What is the ratio of the Gross intake ratio(%) in Equatorial Guinea in 2008 to that in 2012?
Your response must be concise. 1.02. What is the ratio of the Gross intake ratio(%) in Pacific island small states in 2009 to that in 2010?
Your answer should be compact. 0.95. What is the ratio of the Gross intake ratio(%) of Congo (Republic) in 2009 to that in 2010?
Give a very brief answer. 0.97. What is the ratio of the Gross intake ratio(%) in Equatorial Guinea in 2009 to that in 2010?
Provide a succinct answer. 0.96. What is the ratio of the Gross intake ratio(%) of Middle East & North Africa (developing only) in 2009 to that in 2012?
Provide a succinct answer. 0.99. What is the ratio of the Gross intake ratio(%) of Pacific island small states in 2009 to that in 2012?
Keep it short and to the point. 1. What is the ratio of the Gross intake ratio(%) in Congo (Republic) in 2009 to that in 2012?
Your answer should be very brief. 0.98. What is the ratio of the Gross intake ratio(%) of Equatorial Guinea in 2009 to that in 2012?
Your response must be concise. 0.9. What is the ratio of the Gross intake ratio(%) of Middle East & North Africa (developing only) in 2010 to that in 2012?
Offer a terse response. 1. What is the ratio of the Gross intake ratio(%) in Pacific island small states in 2010 to that in 2012?
Keep it short and to the point. 1.05. What is the ratio of the Gross intake ratio(%) of Congo (Republic) in 2010 to that in 2012?
Your answer should be compact. 1.02. What is the ratio of the Gross intake ratio(%) of Equatorial Guinea in 2010 to that in 2012?
Offer a very short reply. 0.94. What is the difference between the highest and the second highest Gross intake ratio(%) in Middle East & North Africa (developing only)?
Ensure brevity in your answer.  0.45. What is the difference between the highest and the second highest Gross intake ratio(%) of Pacific island small states?
Offer a very short reply. 1.99. What is the difference between the highest and the second highest Gross intake ratio(%) in Congo (Republic)?
Your answer should be compact. 1.66. What is the difference between the highest and the second highest Gross intake ratio(%) in Equatorial Guinea?
Offer a very short reply. 2.41. What is the difference between the highest and the lowest Gross intake ratio(%) of Middle East & North Africa (developing only)?
Give a very brief answer. 7.55. What is the difference between the highest and the lowest Gross intake ratio(%) in Pacific island small states?
Offer a terse response. 5.43. What is the difference between the highest and the lowest Gross intake ratio(%) in Congo (Republic)?
Your response must be concise. 35.1. What is the difference between the highest and the lowest Gross intake ratio(%) in Equatorial Guinea?
Provide a short and direct response. 17.14. 